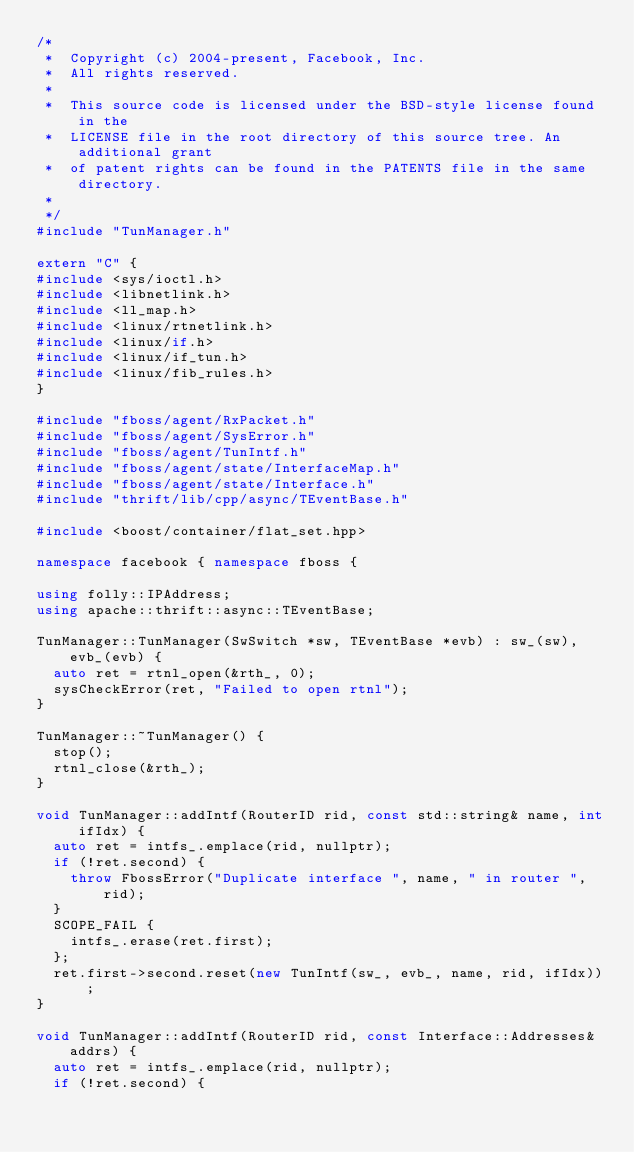Convert code to text. <code><loc_0><loc_0><loc_500><loc_500><_C++_>/*
 *  Copyright (c) 2004-present, Facebook, Inc.
 *  All rights reserved.
 *
 *  This source code is licensed under the BSD-style license found in the
 *  LICENSE file in the root directory of this source tree. An additional grant
 *  of patent rights can be found in the PATENTS file in the same directory.
 *
 */
#include "TunManager.h"

extern "C" {
#include <sys/ioctl.h>
#include <libnetlink.h>
#include <ll_map.h>
#include <linux/rtnetlink.h>
#include <linux/if.h>
#include <linux/if_tun.h>
#include <linux/fib_rules.h>
}

#include "fboss/agent/RxPacket.h"
#include "fboss/agent/SysError.h"
#include "fboss/agent/TunIntf.h"
#include "fboss/agent/state/InterfaceMap.h"
#include "fboss/agent/state/Interface.h"
#include "thrift/lib/cpp/async/TEventBase.h"

#include <boost/container/flat_set.hpp>

namespace facebook { namespace fboss {

using folly::IPAddress;
using apache::thrift::async::TEventBase;

TunManager::TunManager(SwSwitch *sw, TEventBase *evb) : sw_(sw), evb_(evb) {
  auto ret = rtnl_open(&rth_, 0);
  sysCheckError(ret, "Failed to open rtnl");
}

TunManager::~TunManager() {
  stop();
  rtnl_close(&rth_);
}

void TunManager::addIntf(RouterID rid, const std::string& name, int ifIdx) {
  auto ret = intfs_.emplace(rid, nullptr);
  if (!ret.second) {
    throw FbossError("Duplicate interface ", name, " in router ", rid);
  }
  SCOPE_FAIL {
    intfs_.erase(ret.first);
  };
  ret.first->second.reset(new TunIntf(sw_, evb_, name, rid, ifIdx));
}

void TunManager::addIntf(RouterID rid, const Interface::Addresses& addrs) {
  auto ret = intfs_.emplace(rid, nullptr);
  if (!ret.second) {</code> 